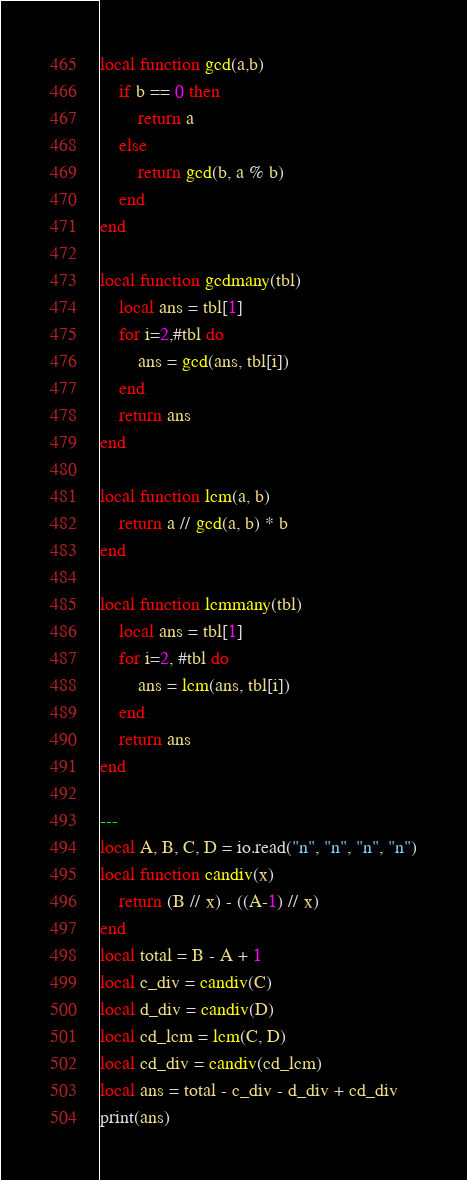<code> <loc_0><loc_0><loc_500><loc_500><_Lua_>local function gcd(a,b)
    if b == 0 then
        return a
    else
        return gcd(b, a % b)
    end
end

local function gcdmany(tbl)
    local ans = tbl[1]
    for i=2,#tbl do
        ans = gcd(ans, tbl[i])
    end
    return ans
end

local function lcm(a, b)
    return a // gcd(a, b) * b
end

local function lcmmany(tbl)
    local ans = tbl[1]
    for i=2, #tbl do
        ans = lcm(ans, tbl[i])
    end
    return ans
end

---
local A, B, C, D = io.read("n", "n", "n", "n")
local function candiv(x)
    return (B // x) - ((A-1) // x)
end
local total = B - A + 1
local c_div = candiv(C)
local d_div = candiv(D)
local cd_lcm = lcm(C, D)
local cd_div = candiv(cd_lcm)
local ans = total - c_div - d_div + cd_div
print(ans)
</code> 